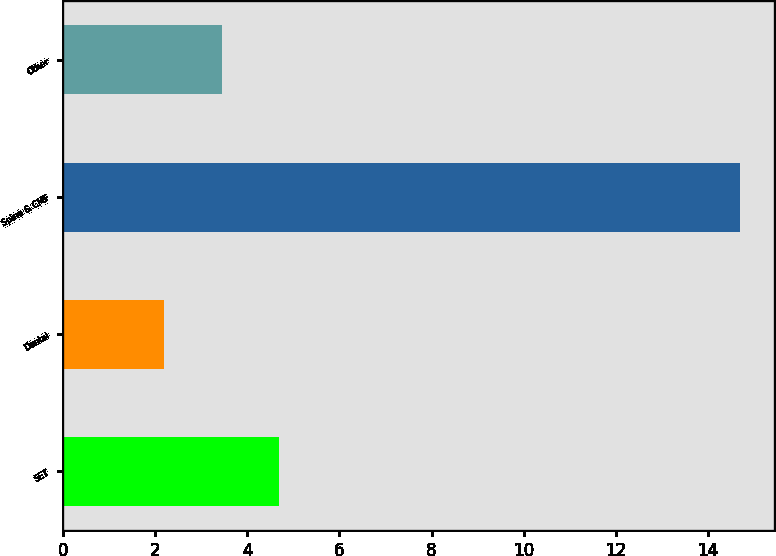Convert chart to OTSL. <chart><loc_0><loc_0><loc_500><loc_500><bar_chart><fcel>SET<fcel>Dental<fcel>Spine & CMF<fcel>Other<nl><fcel>4.7<fcel>2.2<fcel>14.7<fcel>3.45<nl></chart> 